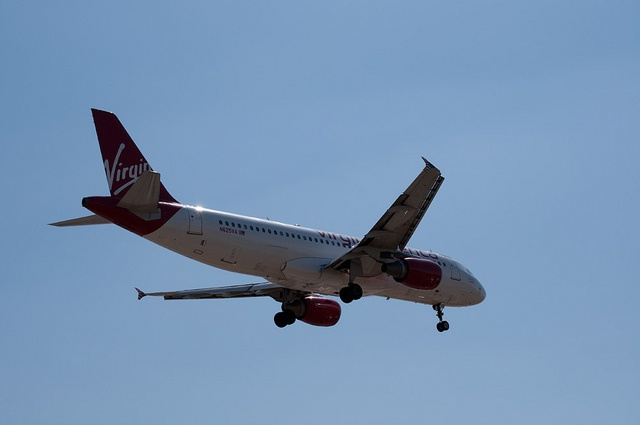Describe the objects in this image and their specific colors. I can see a airplane in gray and black tones in this image. 